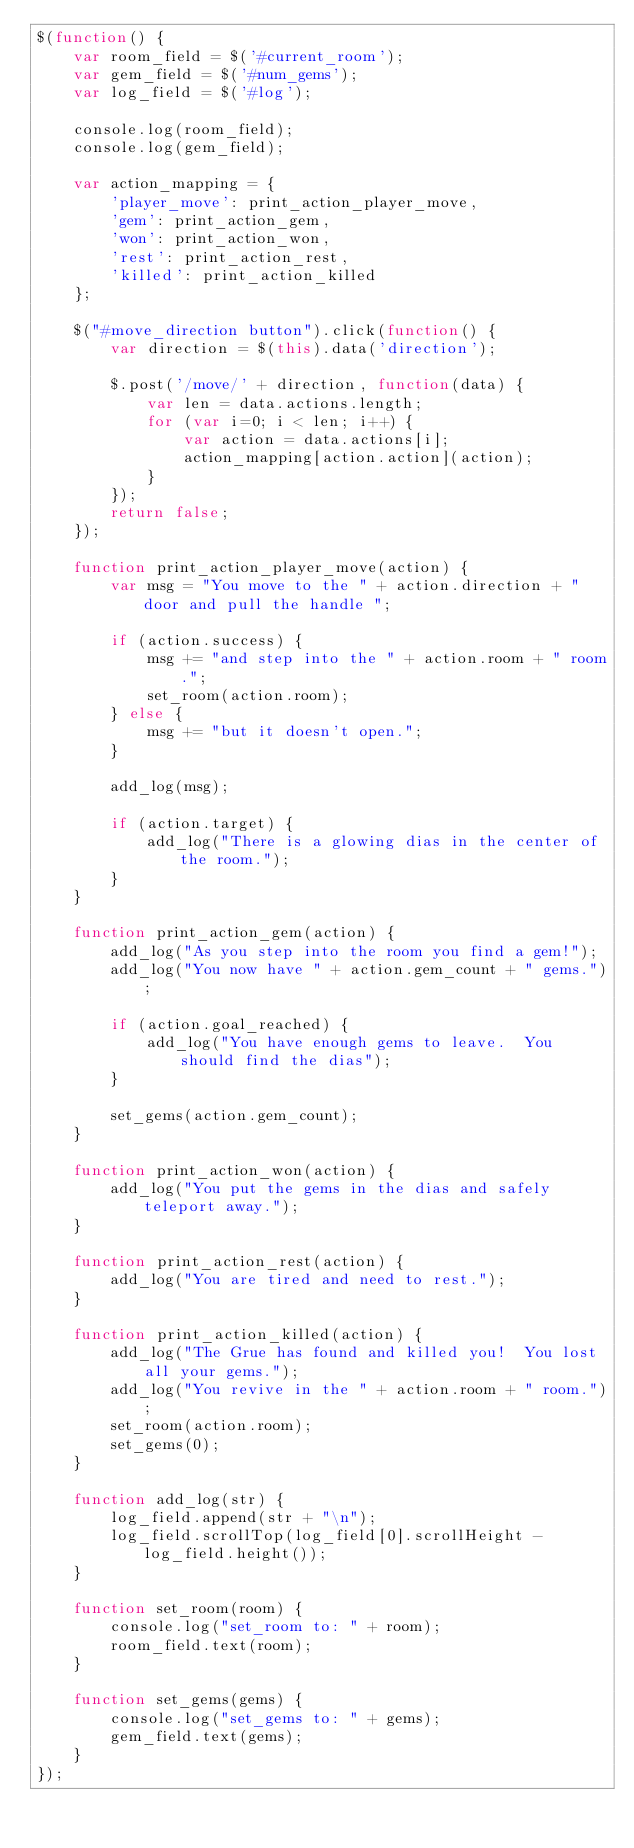Convert code to text. <code><loc_0><loc_0><loc_500><loc_500><_JavaScript_>$(function() {
    var room_field = $('#current_room');
    var gem_field = $('#num_gems');
    var log_field = $('#log');

    console.log(room_field);
    console.log(gem_field);

    var action_mapping = {
        'player_move': print_action_player_move,
        'gem': print_action_gem,
        'won': print_action_won,
        'rest': print_action_rest,
        'killed': print_action_killed
    };

    $("#move_direction button").click(function() {
        var direction = $(this).data('direction');

        $.post('/move/' + direction, function(data) {
            var len = data.actions.length;
            for (var i=0; i < len; i++) {
                var action = data.actions[i];
                action_mapping[action.action](action);
            }
        });
        return false;
    });

    function print_action_player_move(action) {
        var msg = "You move to the " + action.direction + " door and pull the handle ";

        if (action.success) {
            msg += "and step into the " + action.room + " room.";
            set_room(action.room);
        } else {
            msg += "but it doesn't open.";
        }

        add_log(msg);

        if (action.target) {
            add_log("There is a glowing dias in the center of the room.");
        }
    }

    function print_action_gem(action) {
        add_log("As you step into the room you find a gem!");
        add_log("You now have " + action.gem_count + " gems.");

        if (action.goal_reached) {
            add_log("You have enough gems to leave.  You should find the dias");
        }

        set_gems(action.gem_count);
    }

    function print_action_won(action) {
        add_log("You put the gems in the dias and safely teleport away.");
    }

    function print_action_rest(action) {
        add_log("You are tired and need to rest.");
    }

    function print_action_killed(action) {
        add_log("The Grue has found and killed you!  You lost all your gems.");
        add_log("You revive in the " + action.room + " room.");
        set_room(action.room);
        set_gems(0);
    }

    function add_log(str) {
        log_field.append(str + "\n");
        log_field.scrollTop(log_field[0].scrollHeight - log_field.height());
    }

    function set_room(room) {
        console.log("set_room to: " + room);
        room_field.text(room);
    }

    function set_gems(gems) {
        console.log("set_gems to: " + gems);
        gem_field.text(gems);
    }
});
</code> 